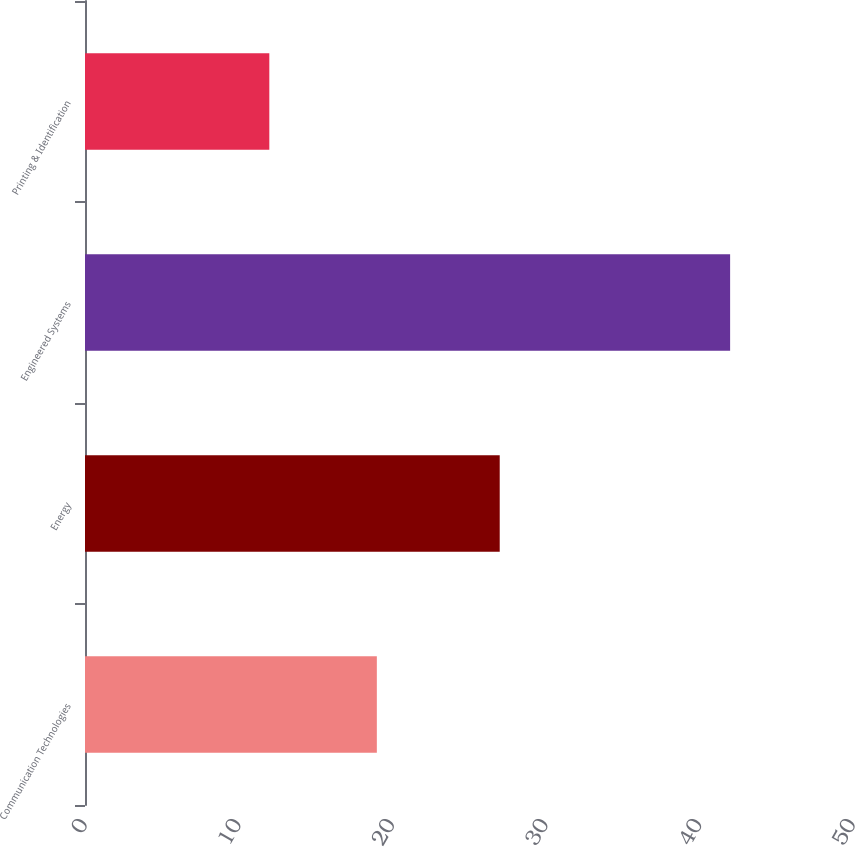Convert chart. <chart><loc_0><loc_0><loc_500><loc_500><bar_chart><fcel>Communication Technologies<fcel>Energy<fcel>Engineered Systems<fcel>Printing & Identification<nl><fcel>19<fcel>27<fcel>42<fcel>12<nl></chart> 